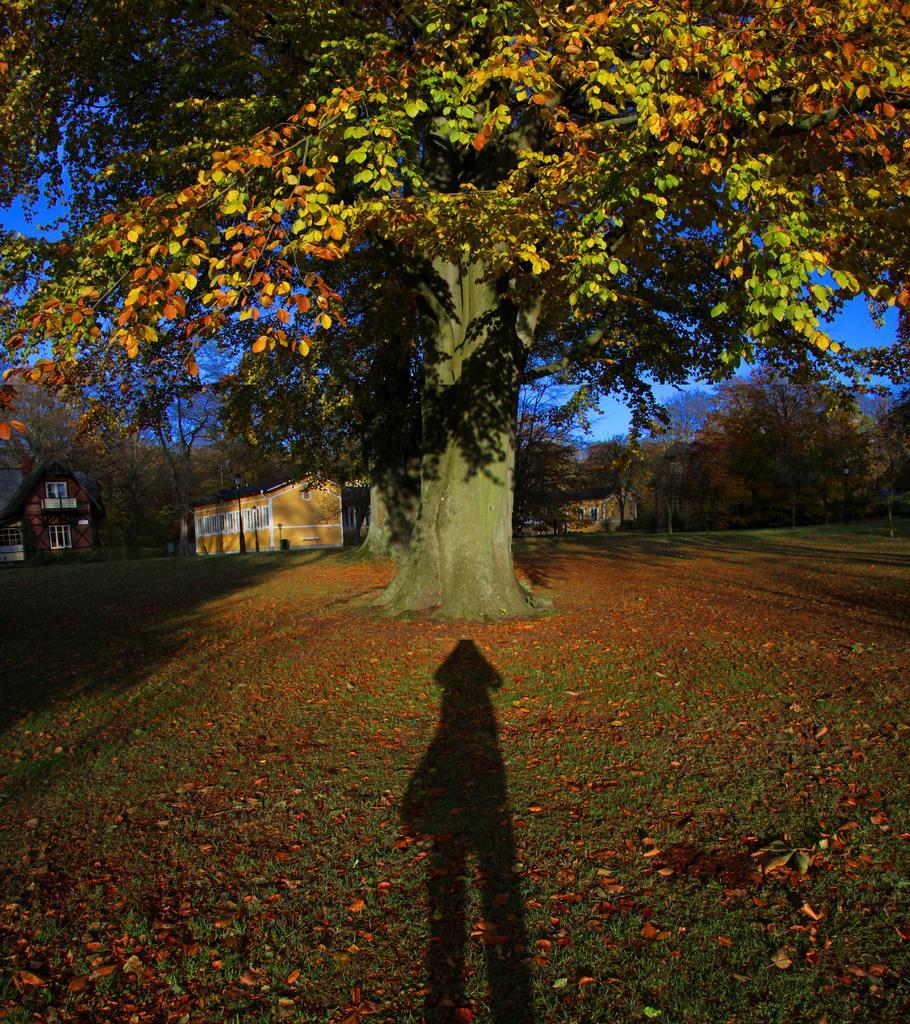Can you describe this image briefly? In the picture I can see the shadow of an object, we can see dry leaves on the ground, we can see trees, houses and the blue color sky in the ground. 